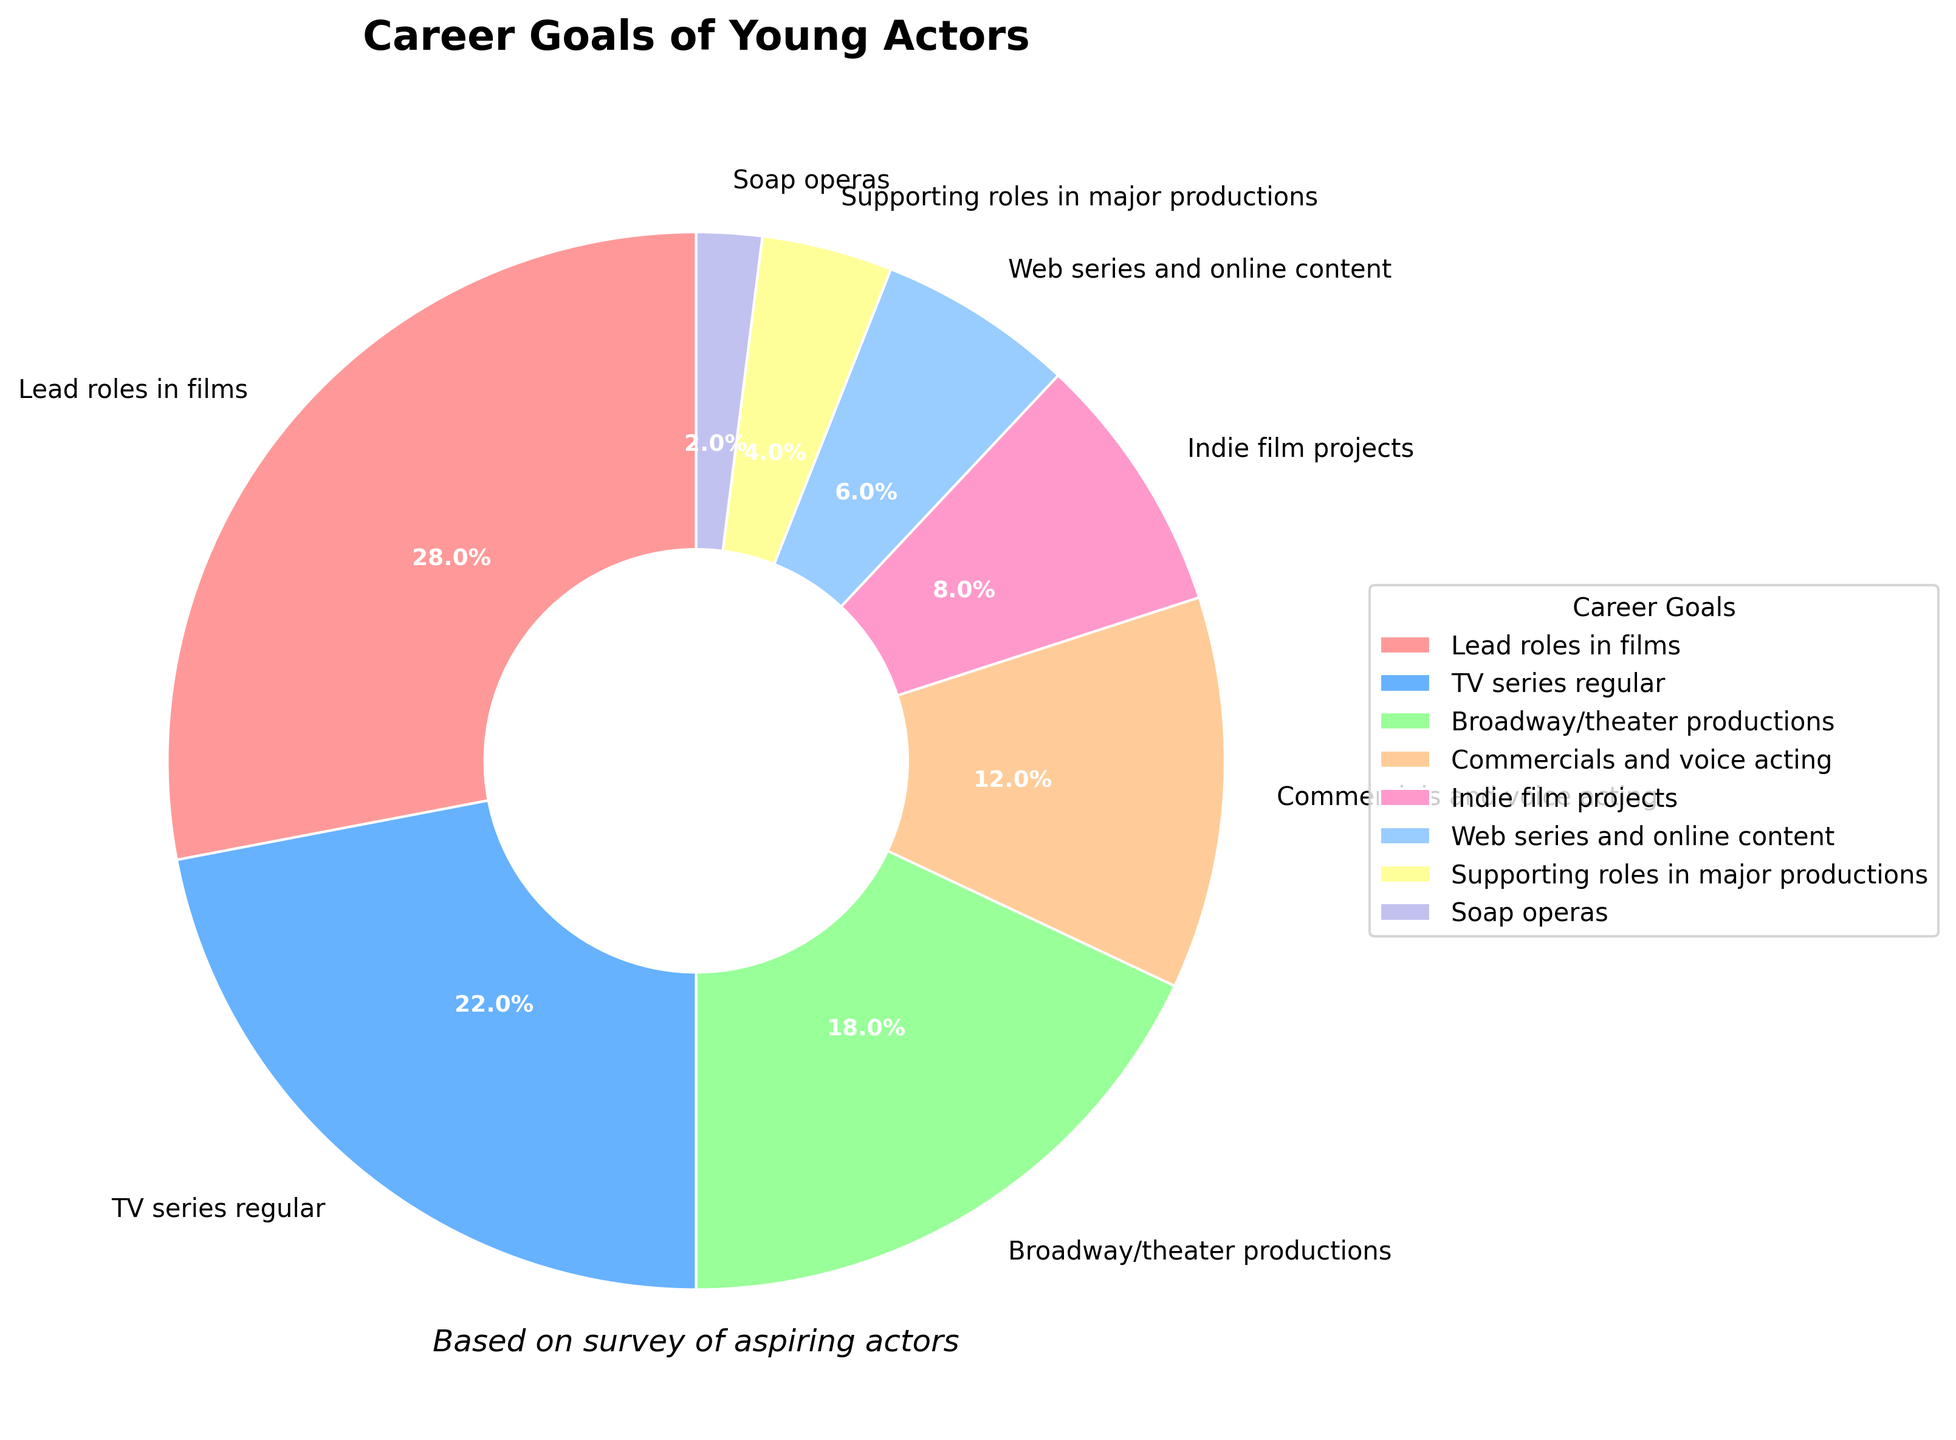What percentage of young actors aim for lead roles in films? The figure shows that 28% of young actors aim for lead roles in films. This information is clearly labeled on the pie chart under the category "Lead roles in films" with the percentage indicated.
Answer: 28% What is the combined percentage of young actors aiming for TV series regulars and Broadway/theater productions? The figure shows that 22% of young actors aim for TV series regulars and 18% for Broadway/theater productions. Adding these two percentages together gives 22% + 18% = 40%.
Answer: 40% Which category has the smallest percentage of career goals among young actors? The smallest segment on the pie chart represents the category "Soap operas" with a percentage of 2%. This is visually the smallest slice and also labeled with the lowest percentage.
Answer: Soap operas Are there more young actors aiming for commercials and voice acting than for indie film projects? Yes, the percentage for commercials and voice acting is 12%, which is greater than the percentage for indie film projects at 8%. This comparison can be seen visually on the pie chart and confirmed by the labeled percentages.
Answer: Yes What is the average percentage of young actors interested in web series and online content and supporting roles in major productions? The percentages for web series and online content and supporting roles in major productions are 6% and 4%, respectively. The average is calculated as (6% + 4%) / 2 = 5%.
Answer: 5% What is the difference in percentage between young actors aiming for lead roles in films and those aiming for TV series regular? The percentage for lead roles in films is 28%, and for TV series regular is 22%. The difference is 28% - 22% = 6%.
Answer: 6% Which category has a larger percentage: indie film projects or web series and online content? The category "Indie film projects" has a percentage of 8%, which is larger than "Web series and online content" at 6%. This comparison can be verified both visually and by the labeled percentages.
Answer: Indie film projects What fraction of young actors aim for Broadway/theater productions out of those aiming for either lead roles in films, TV series regular, or Broadway/theater productions? The combined percentage for actors aiming for lead roles in films, TV series regular, and Broadway/theater productions is 28% + 22% + 18% = 68%. The fraction of those aiming for Broadway/theater productions is 18% of this combined percentage, which is 18/68 or approximately 26.5%.
Answer: 26.5% How many categories have a percentage greater than 10%? The categories with percentages greater than 10% are lead roles in films (28%), TV series regular (22%), Broadway/theater productions (18%), and commercials and voice acting (12%). There are 4 categories in total with a percentage greater than 10%.
Answer: 4 What is the combined percentage of the three least common career goals? The three least common career goals are supporting roles in major productions (4%), web series and online content (6%), and soap operas (2%). Adding these percentages together gives 4% + 6% + 2% = 12%.
Answer: 12% 